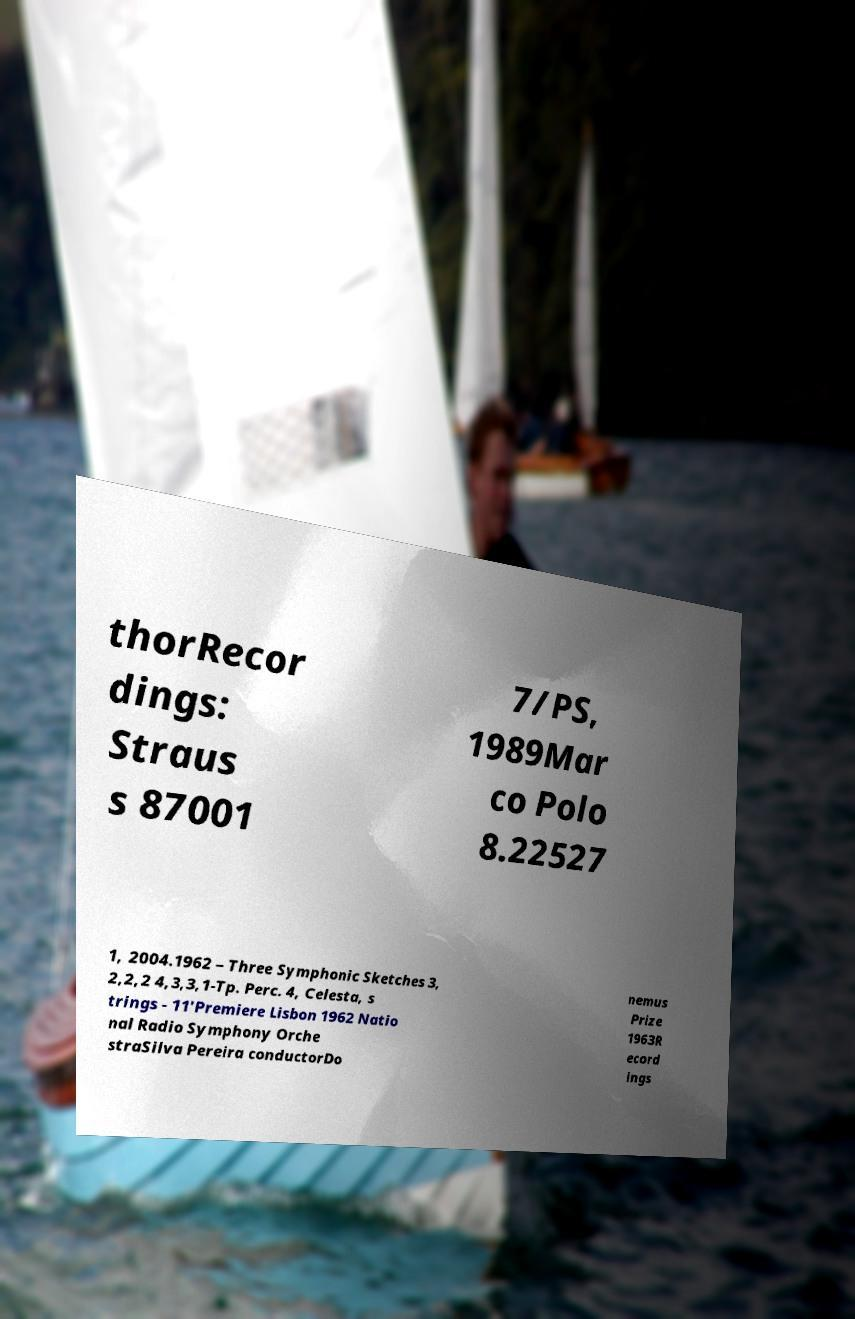There's text embedded in this image that I need extracted. Can you transcribe it verbatim? thorRecor dings: Straus s 87001 7/PS, 1989Mar co Polo 8.22527 1, 2004.1962 – Three Symphonic Sketches 3, 2,2,2 4,3,3,1-Tp. Perc. 4, Celesta, s trings - 11'Premiere Lisbon 1962 Natio nal Radio Symphony Orche straSilva Pereira conductorDo nemus Prize 1963R ecord ings 